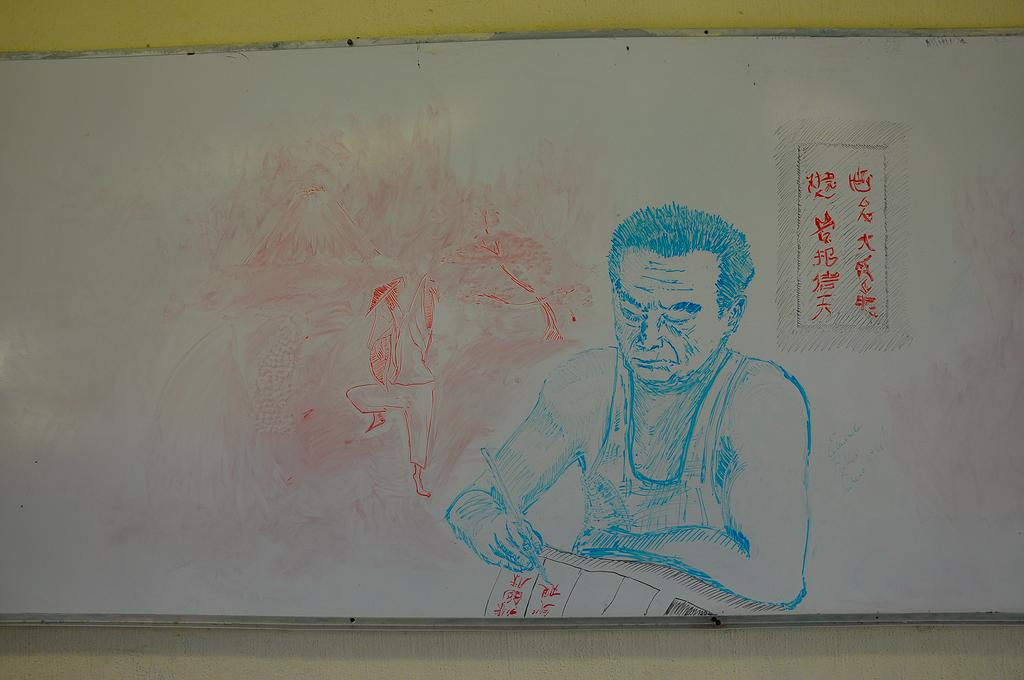What is depicted in the drawing in the image? There is a drawing of two persons in the image. What can be seen on the whiteboard in the image? There is writing on a whiteboard in the image. What is located behind the whiteboard in the image? There is a wall behind the whiteboard in the image. How many steps does the hen take in the image? There is no hen present in the image, so it is not possible to determine how many steps it might take. 